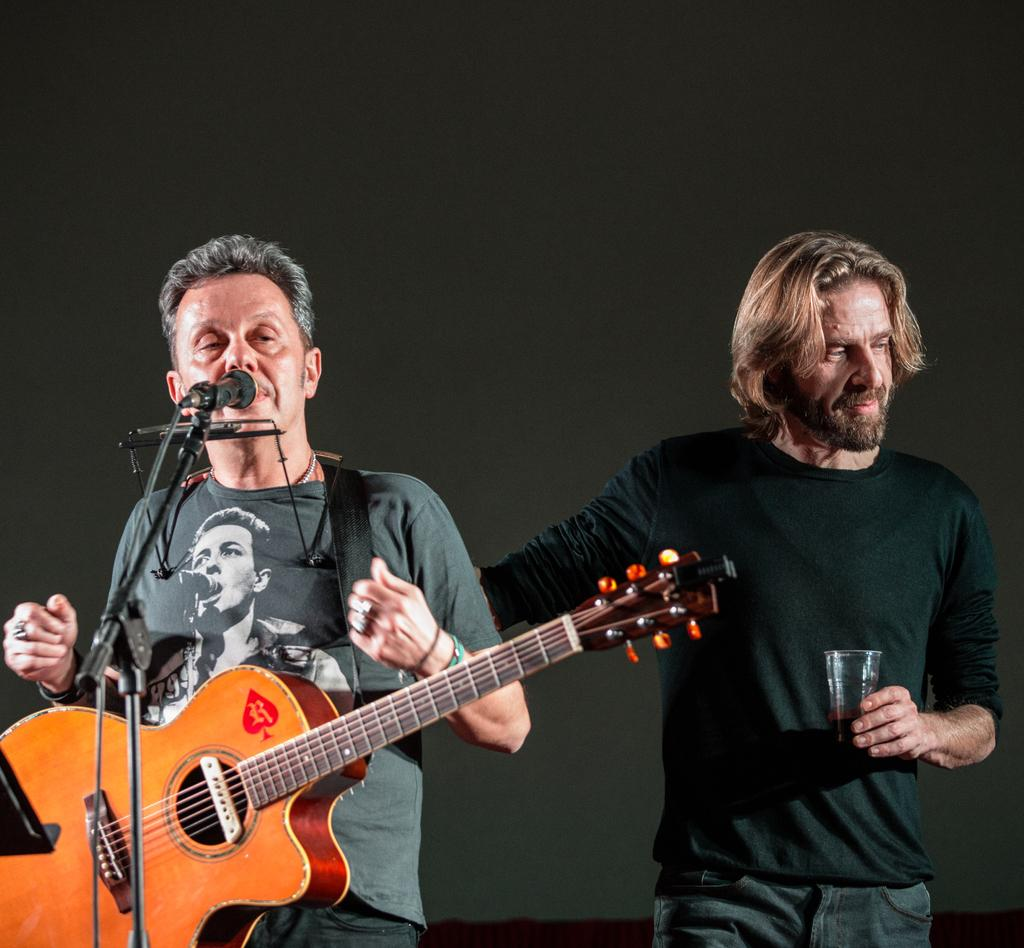How many people are in the image? There are two persons in the image. What is the man on the left side doing? The man on the left side is singing. What instrument is the man on the left side holding? The man on the left side is holding a guitar. What object is the man on the left side standing in front of? The man on the left side is in front of a microphone. What is the person on the right side holding? The person on the right side is holding a glass in his hands. Can you tell me what type of car is parked near the sea in the image? There is no car or sea present in the image; it features two persons, one of whom is singing and holding a guitar. 